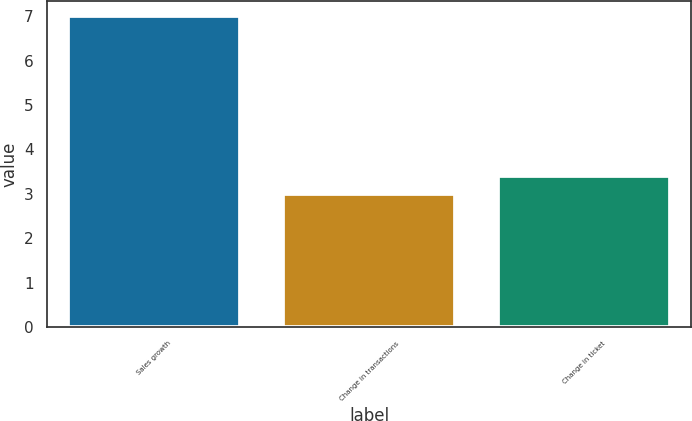Convert chart. <chart><loc_0><loc_0><loc_500><loc_500><bar_chart><fcel>Sales growth<fcel>Change in transactions<fcel>Change in ticket<nl><fcel>7<fcel>3<fcel>3.4<nl></chart> 